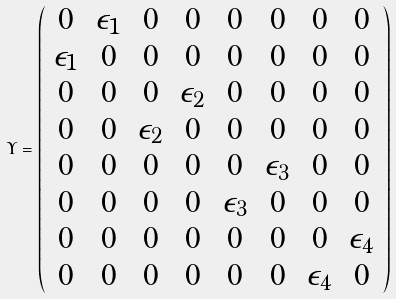Convert formula to latex. <formula><loc_0><loc_0><loc_500><loc_500>\Upsilon = \left ( \begin{array} { c c c c c c c c c c c c c c c c } 0 & \epsilon _ { 1 } & 0 & 0 & 0 & 0 & 0 & 0 \\ \epsilon _ { 1 } & 0 & 0 & 0 & 0 & 0 & 0 & 0 \\ 0 & 0 & 0 & \epsilon _ { 2 } & 0 & 0 & 0 & 0 \\ 0 & 0 & \epsilon _ { 2 } & 0 & 0 & 0 & 0 & 0 \\ 0 & 0 & 0 & 0 & 0 & \epsilon _ { 3 } & 0 & 0 \\ 0 & 0 & 0 & 0 & \epsilon _ { 3 } & 0 & 0 & 0 \\ 0 & 0 & 0 & 0 & 0 & 0 & 0 & \epsilon _ { 4 } \\ 0 & 0 & 0 & 0 & 0 & 0 & \epsilon _ { 4 } & 0 \\ \end{array} \right )</formula> 